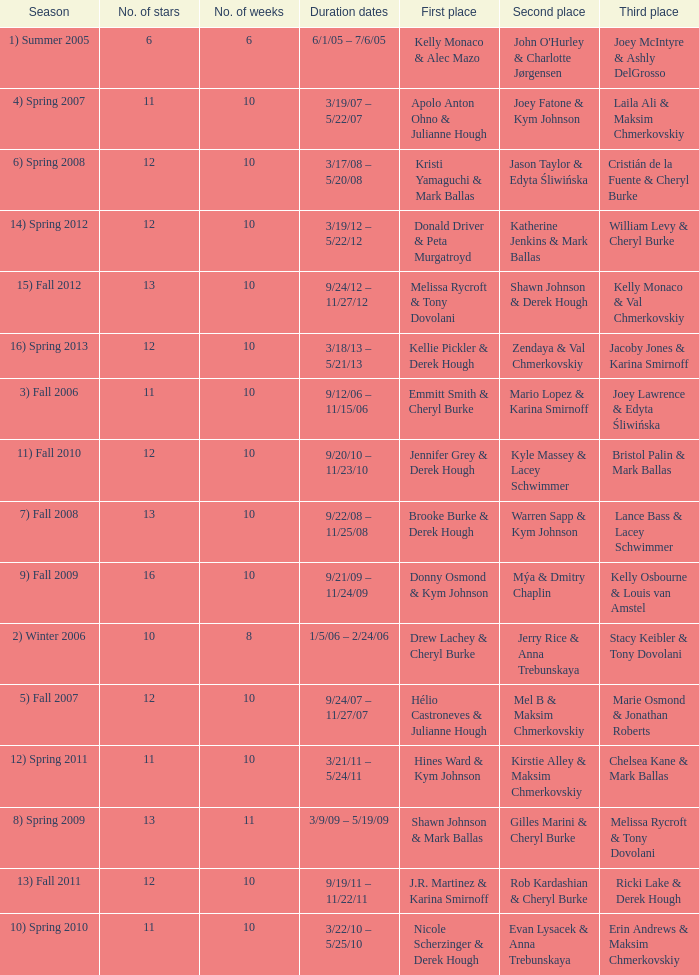Who took first place in week 6? 1.0. 